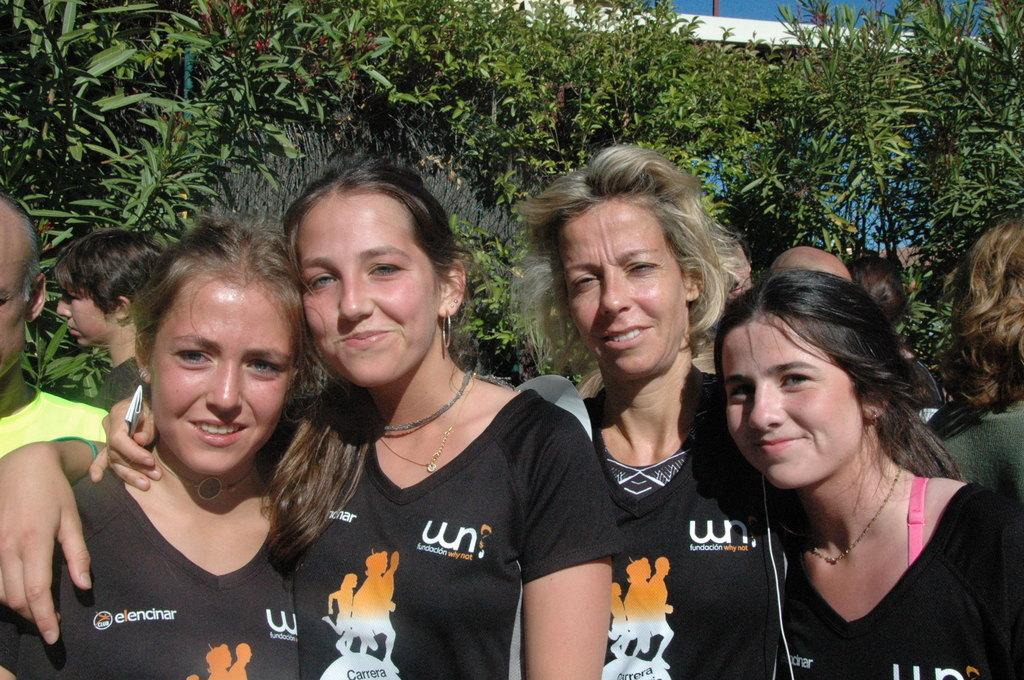What is the primary subject of the image? There are women standing in the image. What is the surface on which the women are standing? The women are standing on the ground. Can you describe the background of the image? There are persons, trees, a wall, and the sky visible in the background of the image. Is the ground made of quicksand in the image? No, the ground is not made of quicksand in the image; it appears to be a solid surface on which the women are standing. What type of quilt is draped over the wall in the image? There is no quilt present in the image; only the women, the ground, and the background elements are visible. 